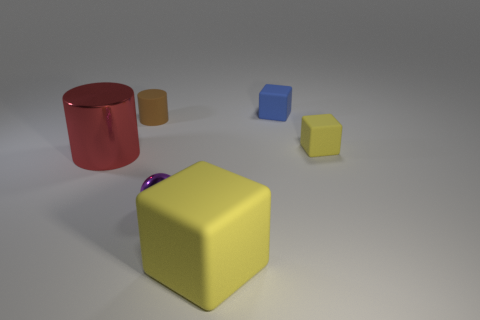Is the number of tiny brown matte things that are on the left side of the ball greater than the number of small purple balls to the left of the brown object?
Your answer should be compact. Yes. How many blue blocks have the same size as the purple metallic object?
Your answer should be compact. 1. Is the number of purple objects to the right of the ball less than the number of small purple shiny balls right of the rubber cylinder?
Keep it short and to the point. Yes. Are there any other objects of the same shape as the small brown rubber thing?
Your response must be concise. Yes. Is the tiny brown rubber thing the same shape as the tiny yellow thing?
Your answer should be very brief. No. How many tiny things are either red cylinders or cyan metal objects?
Offer a very short reply. 0. Is the number of small yellow cubes greater than the number of tiny green cylinders?
Offer a very short reply. Yes. What size is the red cylinder that is the same material as the small purple object?
Provide a succinct answer. Large. There is a matte thing left of the big cube; is its size the same as the matte thing in front of the big red cylinder?
Keep it short and to the point. No. How many things are either yellow rubber things behind the large red shiny object or matte things?
Give a very brief answer. 4. 